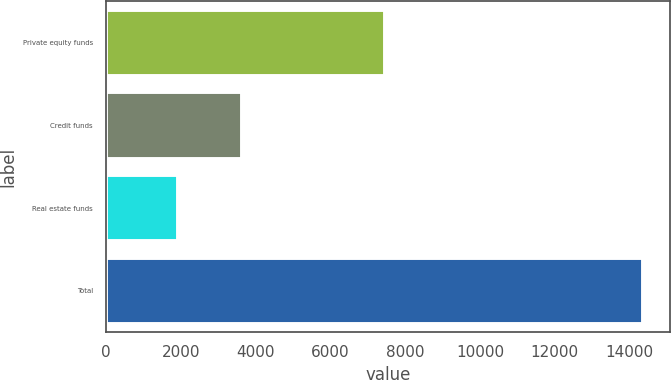Convert chart. <chart><loc_0><loc_0><loc_500><loc_500><bar_chart><fcel>Private equity funds<fcel>Credit funds<fcel>Real estate funds<fcel>Total<nl><fcel>7446<fcel>3624<fcel>1908<fcel>14372<nl></chart> 